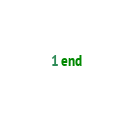<code> <loc_0><loc_0><loc_500><loc_500><_Ruby_>end
</code> 